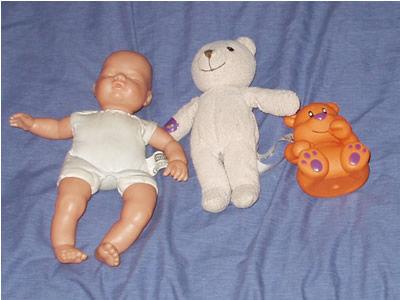Which toy is in the middle?
Short answer required. Teddy bear. What color is the smaller bear?
Write a very short answer. Brown. Are the baby toys?
Give a very brief answer. Yes. Are the animals made of felt?
Concise answer only. No. Does the baby doll have eyes?
Keep it brief. No. 